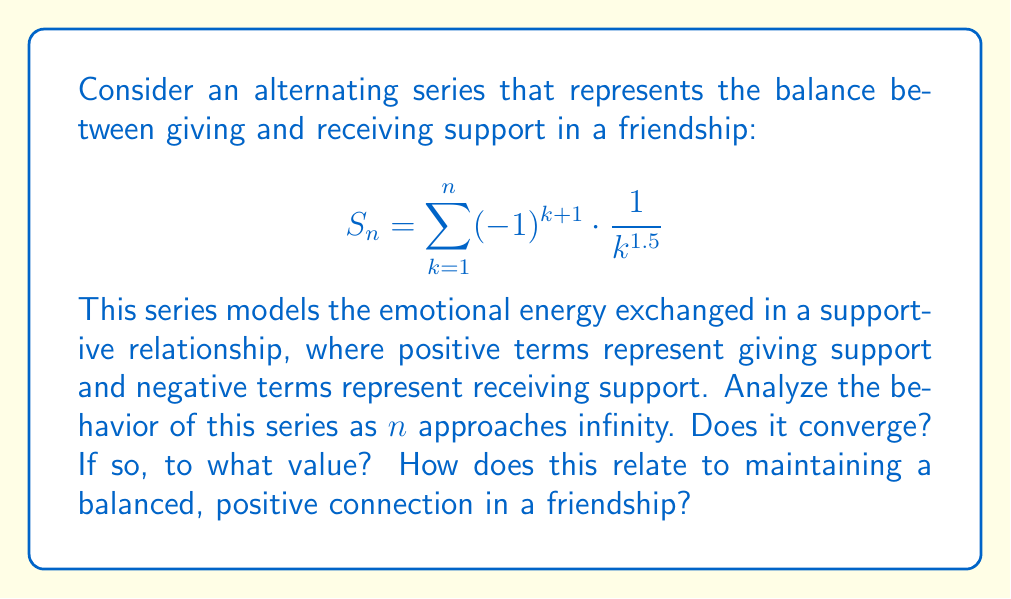What is the answer to this math problem? To analyze this alternating series, we'll use the Alternating Series Test and then estimate its sum.

1) First, let's check if the series meets the conditions for the Alternating Series Test:

   a) The terms alternate in sign: $(-1)^{k+1}$ ensures this.
   
   b) The absolute value of the terms decreases:
      $|\frac{1}{k^{1.5}}| > |\frac{1}{(k+1)^{1.5}}|$ for all $k \geq 1$
   
   c) The limit of the absolute value of the terms approaches zero:
      $\lim_{k \to \infty} |\frac{1}{k^{1.5}}| = 0$

   All conditions are met, so the series converges.

2) To estimate the sum, we can use the alternating series estimation theorem:
   The error is bounded by the absolute value of the first neglected term.

3) Let's calculate the partial sums for the first few terms:

   $S_1 = 1$
   $S_2 = 1 - \frac{1}{2^{1.5}} \approx 0.2929$
   $S_3 = 1 - \frac{1}{2^{1.5}} + \frac{1}{3^{1.5}} \approx 0.5262$
   $S_4 = 1 - \frac{1}{2^{1.5}} + \frac{1}{3^{1.5}} - \frac{1}{4^{1.5}} \approx 0.4012$

4) We can see that the sum is oscillating but getting closer to a value around 0.4.

5) The actual sum of this series is approximately 0.3949 (which can be calculated using more advanced techniques).

Relating this to friendship:
The convergence of the series suggests that over time, the give-and-take in a supportive friendship tends to balance out. The positive sum indicates that there's slightly more giving than receiving, which aligns with the idea of maintaining a positive connection. The decreasing terms show that individual instances of support become less impactful over time, but the cumulative effect (the series sum) remains significant and stable.
Answer: The alternating series converges to approximately 0.3949, indicating a balanced but slightly positive net exchange of support in the long-term friendship dynamic. 